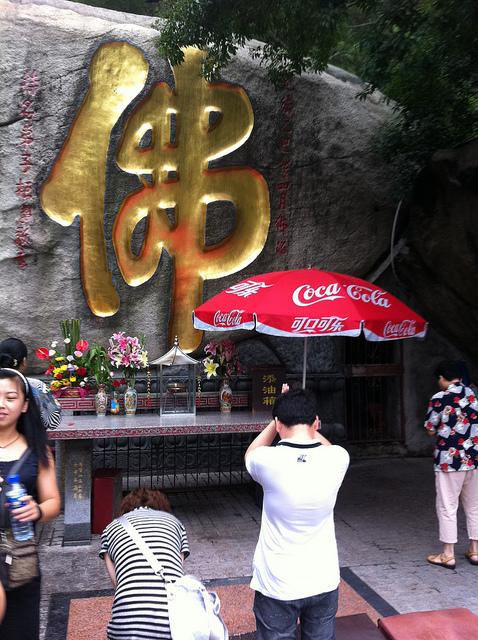What Pantone is Coca Cola red? umbrella 